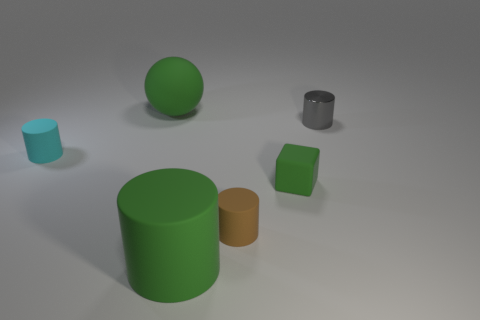Add 2 green rubber things. How many objects exist? 8 Subtract all spheres. How many objects are left? 5 Subtract 0 purple balls. How many objects are left? 6 Subtract all cyan objects. Subtract all small purple spheres. How many objects are left? 5 Add 4 gray objects. How many gray objects are left? 5 Add 3 big purple rubber cubes. How many big purple rubber cubes exist? 3 